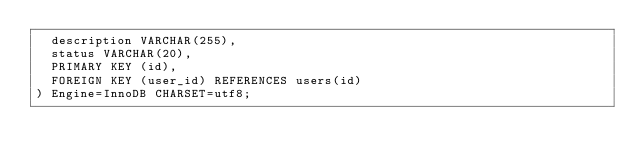Convert code to text. <code><loc_0><loc_0><loc_500><loc_500><_SQL_>  description VARCHAR(255),
  status VARCHAR(20),
  PRIMARY KEY (id),
  FOREIGN KEY (user_id) REFERENCES users(id)
) Engine=InnoDB CHARSET=utf8;
</code> 